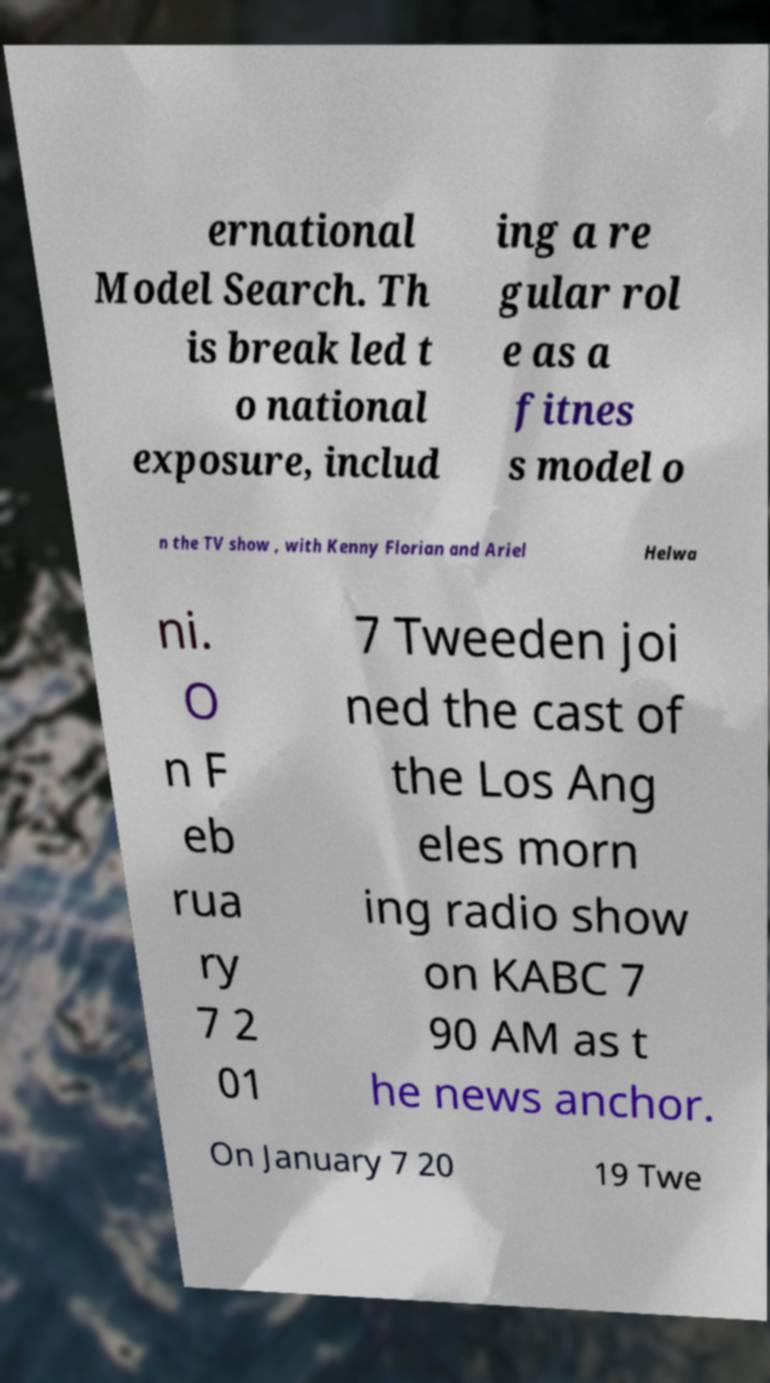Can you accurately transcribe the text from the provided image for me? ernational Model Search. Th is break led t o national exposure, includ ing a re gular rol e as a fitnes s model o n the TV show , with Kenny Florian and Ariel Helwa ni. O n F eb rua ry 7 2 01 7 Tweeden joi ned the cast of the Los Ang eles morn ing radio show on KABC 7 90 AM as t he news anchor. On January 7 20 19 Twe 